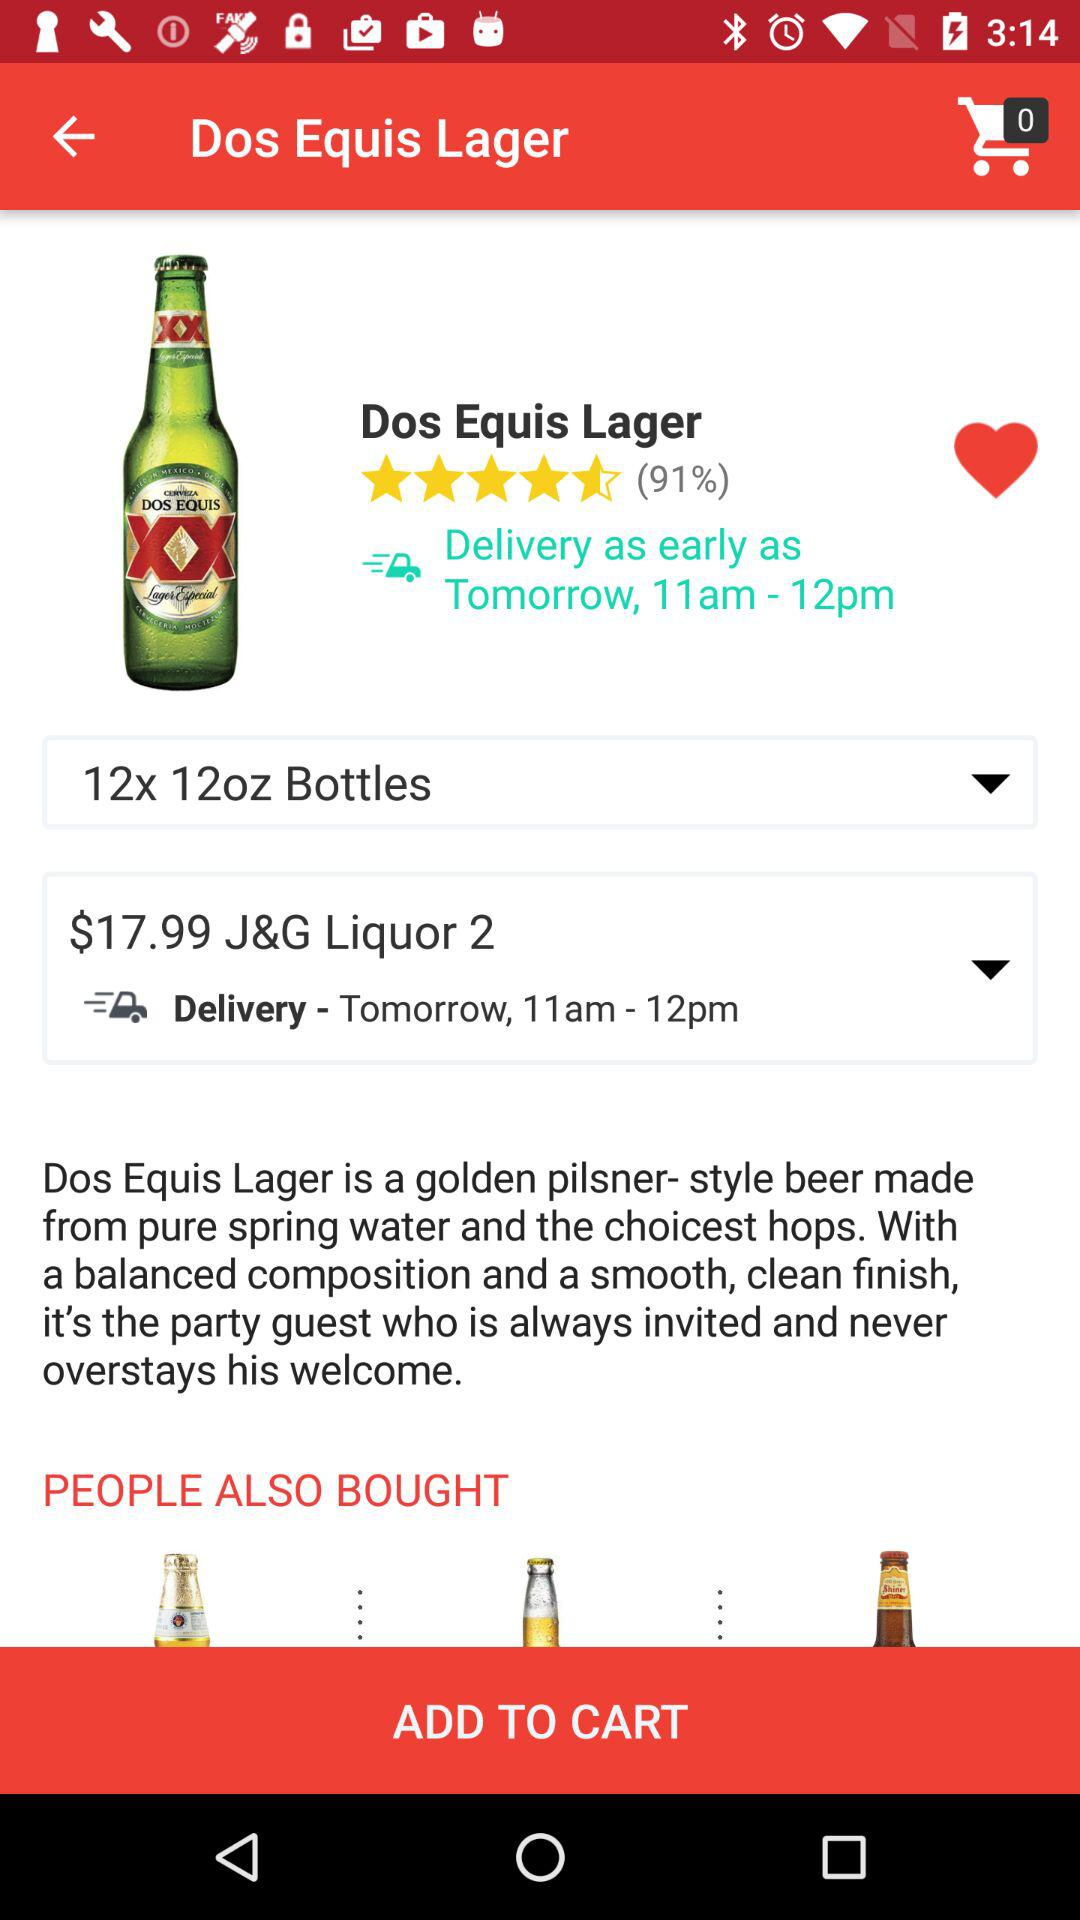What is the percentage of the rating? The percentage of the rating is 91. 